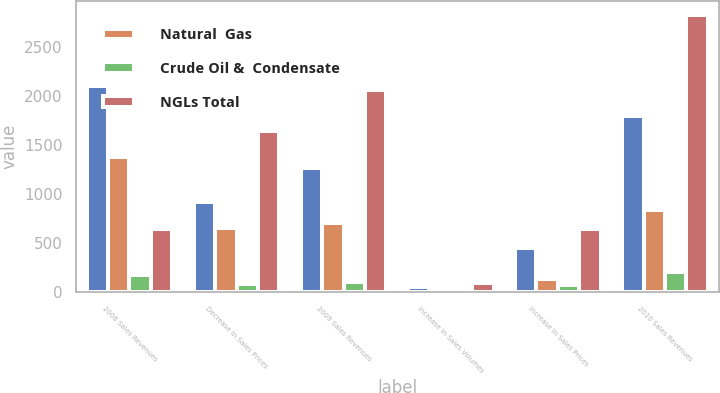Convert chart. <chart><loc_0><loc_0><loc_500><loc_500><stacked_bar_chart><ecel><fcel>2008 Sales Revenues<fcel>Decrease in Sales Prices<fcel>2009 Sales Revenues<fcel>Increase in Sales Volumes<fcel>Increase in Sales Prices<fcel>2010 Sales Revenues<nl><fcel>nan<fcel>2101<fcel>915<fcel>1261<fcel>48<fcel>447<fcel>1795<nl><fcel>Natural  Gas<fcel>1375<fcel>655<fcel>701<fcel>5<fcel>129<fcel>834<nl><fcel>Crude Oil &  Condensate<fcel>175<fcel>77<fcel>98<fcel>40<fcel>65<fcel>203<nl><fcel>NGLs Total<fcel>641<fcel>1647<fcel>2060<fcel>93<fcel>641<fcel>2832<nl></chart> 